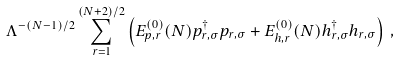Convert formula to latex. <formula><loc_0><loc_0><loc_500><loc_500>\Lambda ^ { - ( N - 1 ) / 2 } \sum _ { r = 1 } ^ { ( N + 2 ) / 2 } \left ( E ^ { ( 0 ) } _ { p , r } ( N ) p ^ { \dagger } _ { r , \sigma } p _ { r , \sigma } + E ^ { ( 0 ) } _ { h , r } ( N ) h ^ { \dagger } _ { r , \sigma } h _ { r , \sigma } \right ) \, ,</formula> 